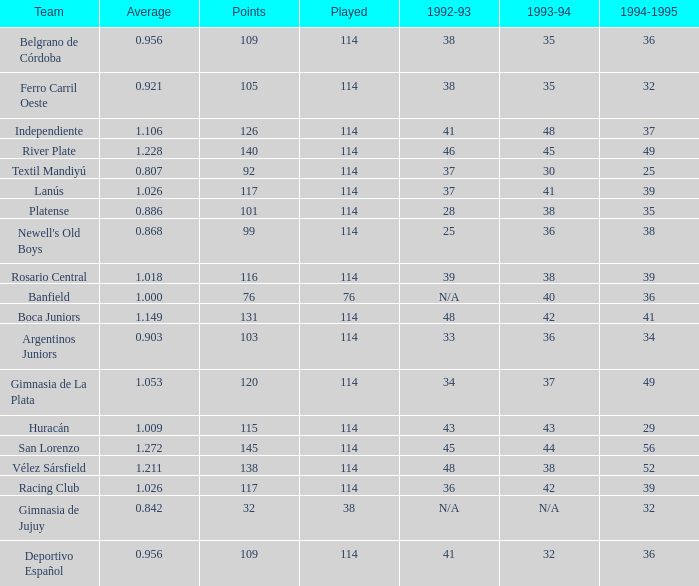Name the most played 114.0. 